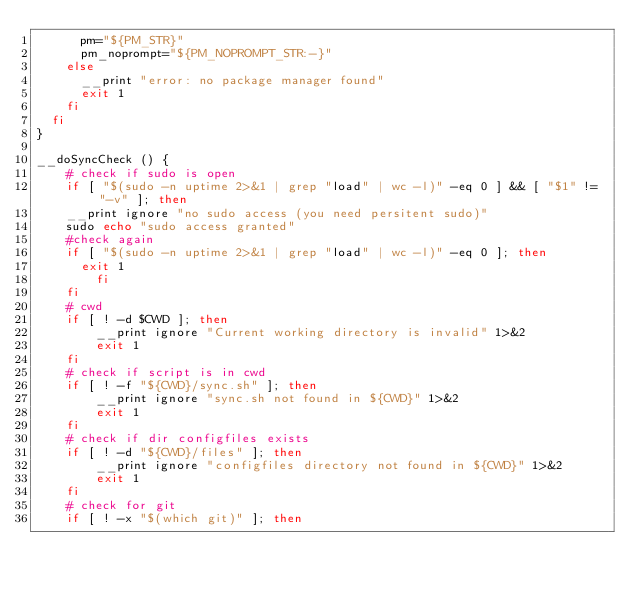<code> <loc_0><loc_0><loc_500><loc_500><_Bash_>      pm="${PM_STR}"
      pm_noprompt="${PM_NOPROMPT_STR:-}"
    else
      __print "error: no package manager found"
      exit 1
    fi
  fi
}

__doSyncCheck () {
	# check if sudo is open
	if [ "$(sudo -n uptime 2>&1 | grep "load" | wc -l)" -eq 0 ] && [ "$1" != "-v" ]; then
    __print ignore "no sudo access (you need persitent sudo)"
    sudo echo "sudo access granted"
    #check again
    if [ "$(sudo -n uptime 2>&1 | grep "load" | wc -l)" -eq 0 ]; then
      exit 1
		fi
	fi
	# cwd
	if [ ! -d $CWD ]; then
		__print ignore "Current working directory is invalid" 1>&2
		exit 1
	fi
	# check if script is in cwd
	if [ ! -f "${CWD}/sync.sh" ]; then
		__print ignore "sync.sh not found in ${CWD}" 1>&2
		exit 1
	fi
	# check if dir configfiles exists
	if [ ! -d "${CWD}/files" ]; then
		__print ignore "configfiles directory not found in ${CWD}" 1>&2
		exit 1
	fi
	# check for git
	if [ ! -x "$(which git)" ]; then</code> 